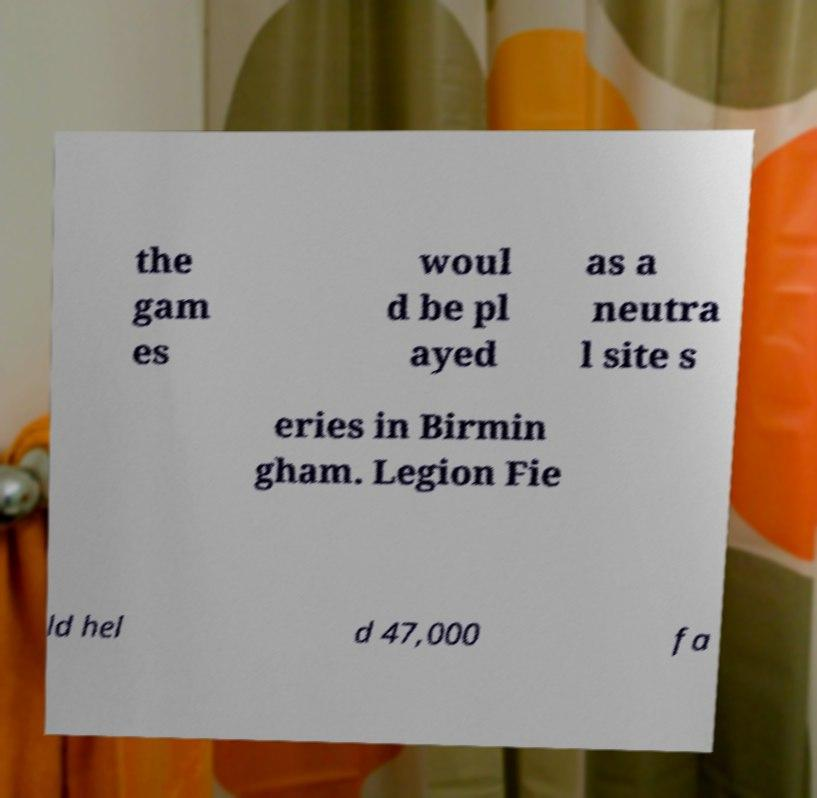There's text embedded in this image that I need extracted. Can you transcribe it verbatim? the gam es woul d be pl ayed as a neutra l site s eries in Birmin gham. Legion Fie ld hel d 47,000 fa 